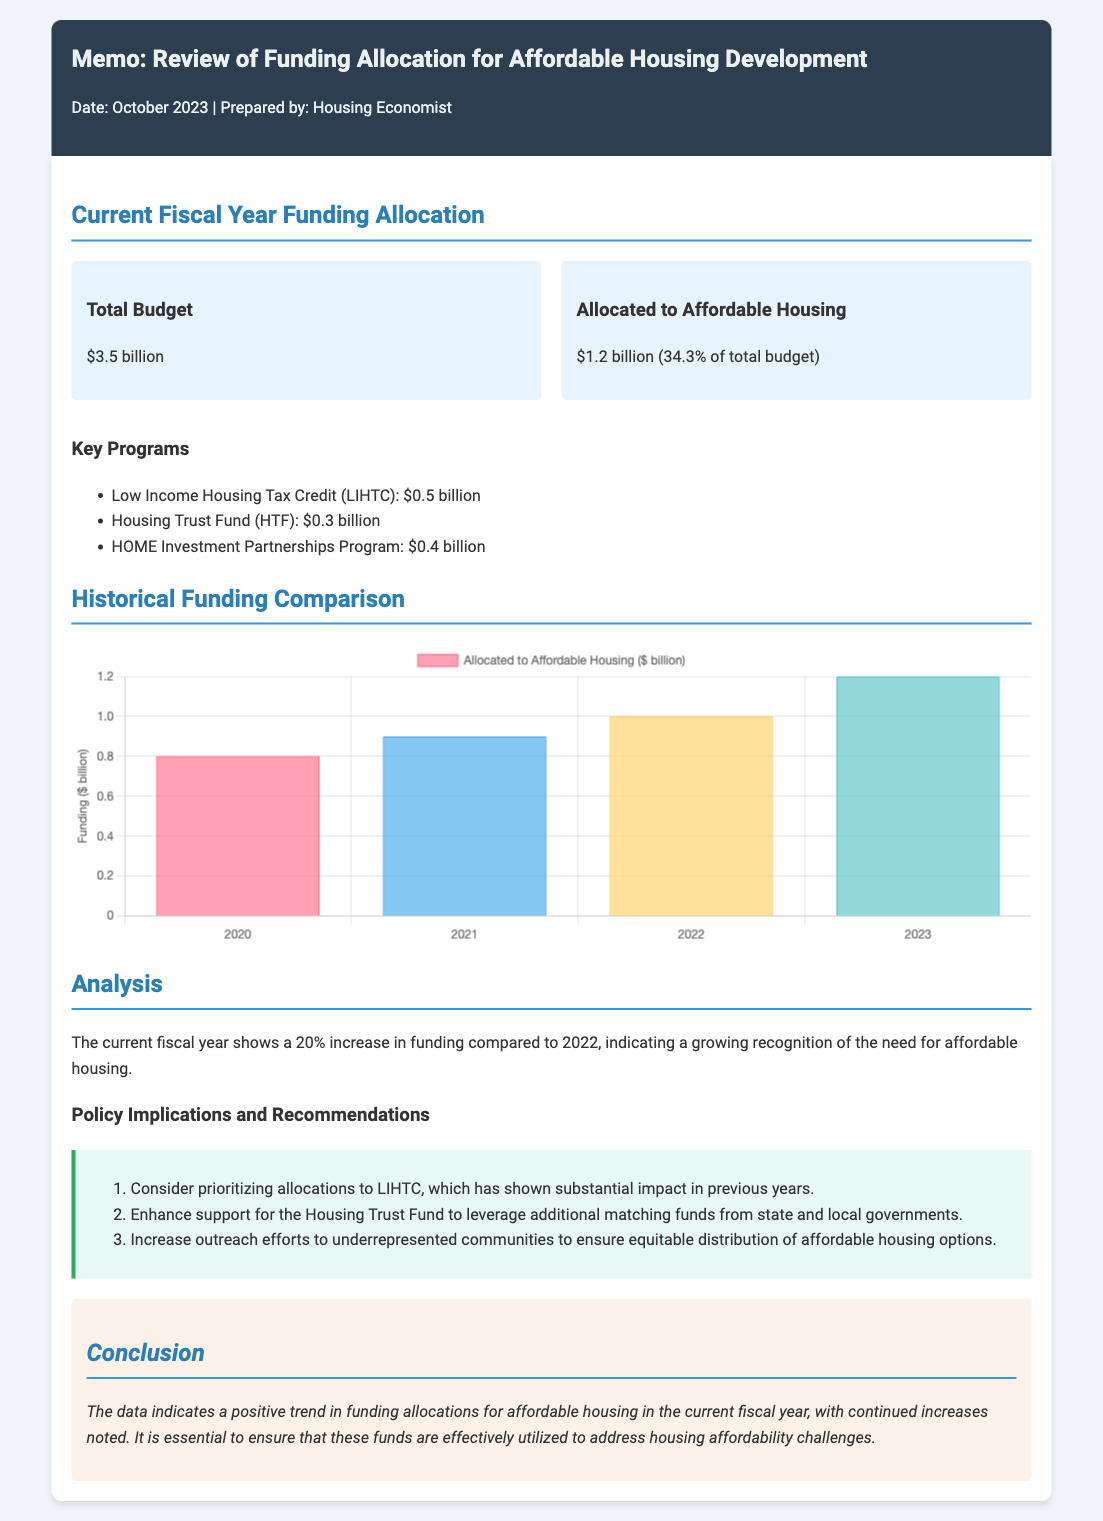What is the total budget for the current fiscal year? The total budget is explicitly stated in the document under "Current Fiscal Year Funding Allocation."
Answer: $3.5 billion How much funding is allocated to affordable housing? The amount allocated to affordable housing is listed alongside the total budget in the "Current Fiscal Year Funding Allocation" section.
Answer: $1.2 billion What percentage of the total budget is allocated to affordable housing? The document includes this information directly after stating the allocation amount.
Answer: 34.3% What is the funding amount for the Low Income Housing Tax Credit (LIHTC)? The funding amount for LIHTC is listed under "Key Programs" in the document.
Answer: $0.5 billion What is the growth percentage in funding compared to the previous year? The document provides this figure in the "Analysis" section, indicating the year-on-year change in funding.
Answer: 20% What does HTF stand for in the context of housing programs? HTF is explicitly defined in the list of key programs in the memo.
Answer: Housing Trust Fund What recommendation is made regarding the Housing Trust Fund? The recommendation is provided in the section detailing "Policy Implications and Recommendations."
Answer: Enhance support What year does the historical funding comparison start from? The years shown in the "Historical Funding Comparison" section indicate this information.
Answer: 2020 How many key programs are listed under Current Fiscal Year Funding Allocation? The number of programs can be counted from the "Key Programs" section of the document.
Answer: 3 